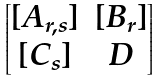Convert formula to latex. <formula><loc_0><loc_0><loc_500><loc_500>\begin{bmatrix} [ A _ { r , s } ] & [ B _ { r } ] \\ [ C _ { s } ] & D \end{bmatrix}</formula> 